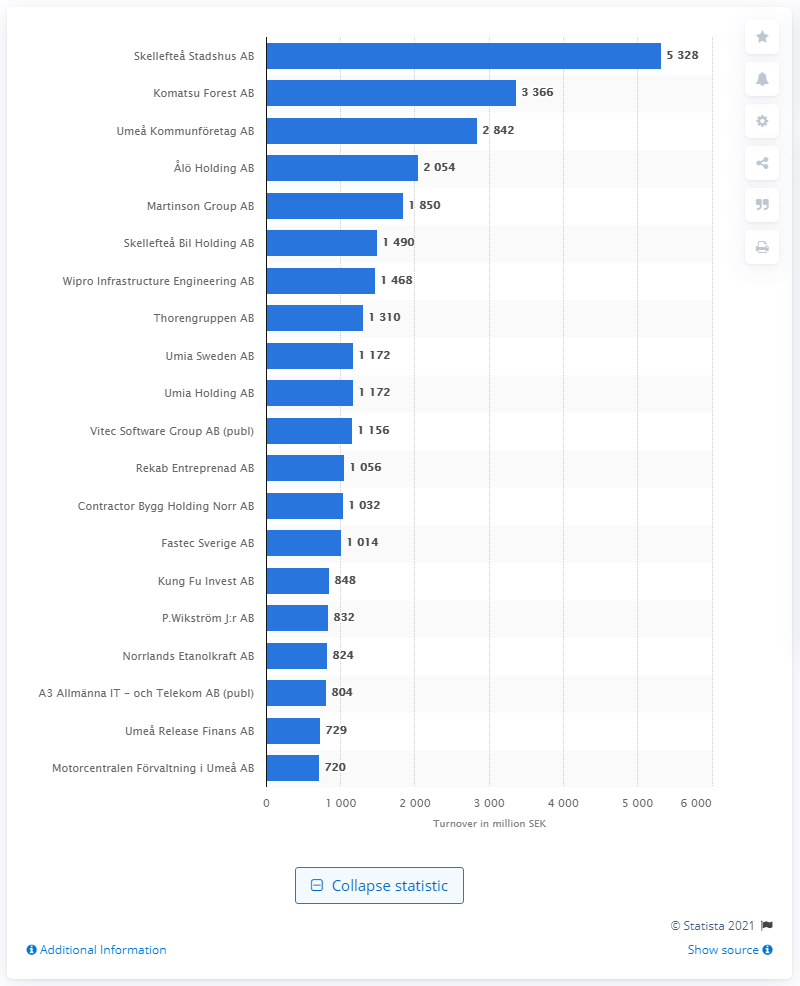Specify some key components in this picture. The turnover of Skellefte Stadshus AB was 5,328. Komatsu Forest AB was ranked second in turnover among companies in Västerbotten county. 